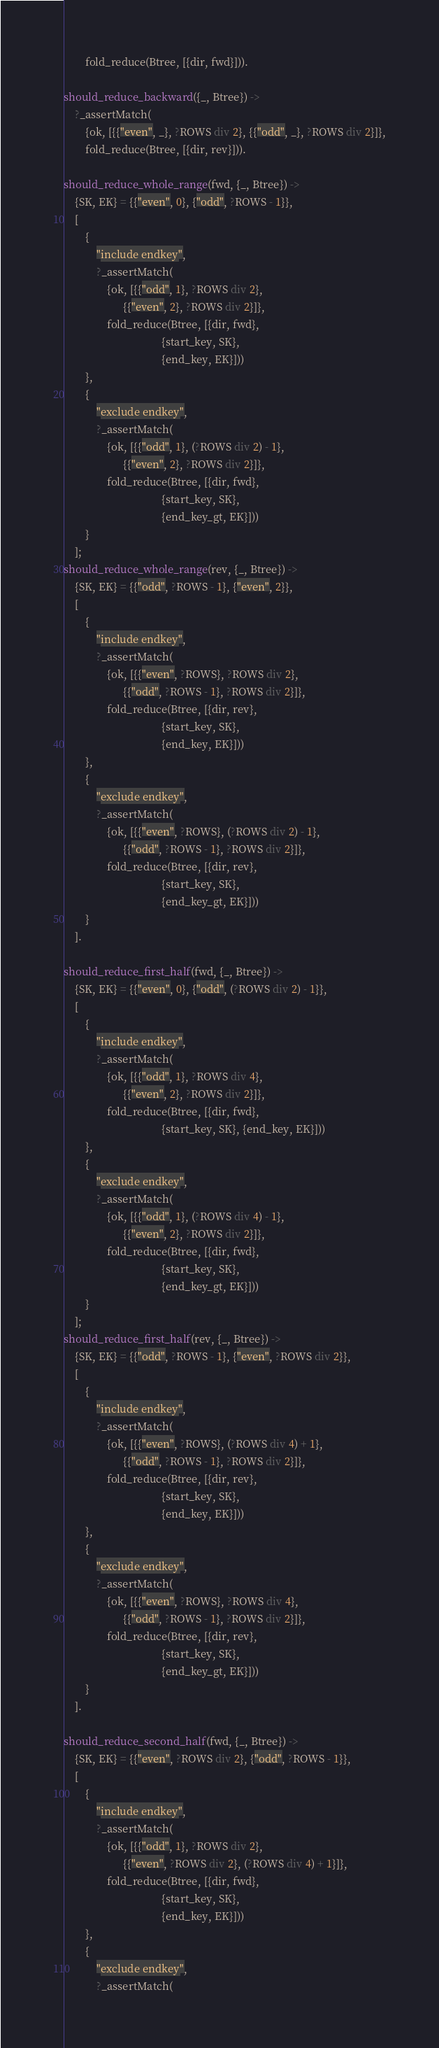<code> <loc_0><loc_0><loc_500><loc_500><_Erlang_>        fold_reduce(Btree, [{dir, fwd}])).

should_reduce_backward({_, Btree}) ->
    ?_assertMatch(
        {ok, [{{"even", _}, ?ROWS div 2}, {{"odd", _}, ?ROWS div 2}]},
        fold_reduce(Btree, [{dir, rev}])).

should_reduce_whole_range(fwd, {_, Btree}) ->
    {SK, EK} = {{"even", 0}, {"odd", ?ROWS - 1}},
    [
        {
            "include endkey",
            ?_assertMatch(
                {ok, [{{"odd", 1}, ?ROWS div 2},
                      {{"even", 2}, ?ROWS div 2}]},
                fold_reduce(Btree, [{dir, fwd},
                                    {start_key, SK},
                                    {end_key, EK}]))
        },
        {
            "exclude endkey",
            ?_assertMatch(
                {ok, [{{"odd", 1}, (?ROWS div 2) - 1},
                      {{"even", 2}, ?ROWS div 2}]},
                fold_reduce(Btree, [{dir, fwd},
                                    {start_key, SK},
                                    {end_key_gt, EK}]))
        }
    ];
should_reduce_whole_range(rev, {_, Btree}) ->
    {SK, EK} = {{"odd", ?ROWS - 1}, {"even", 2}},
    [
        {
            "include endkey",
            ?_assertMatch(
                {ok, [{{"even", ?ROWS}, ?ROWS div 2},
                      {{"odd", ?ROWS - 1}, ?ROWS div 2}]},
                fold_reduce(Btree, [{dir, rev},
                                    {start_key, SK},
                                    {end_key, EK}]))
        },
        {
            "exclude endkey",
            ?_assertMatch(
                {ok, [{{"even", ?ROWS}, (?ROWS div 2) - 1},
                      {{"odd", ?ROWS - 1}, ?ROWS div 2}]},
                fold_reduce(Btree, [{dir, rev},
                                    {start_key, SK},
                                    {end_key_gt, EK}]))
        }
    ].

should_reduce_first_half(fwd, {_, Btree}) ->
    {SK, EK} = {{"even", 0}, {"odd", (?ROWS div 2) - 1}},
    [
        {
            "include endkey",
            ?_assertMatch(
                {ok, [{{"odd", 1}, ?ROWS div 4},
                      {{"even", 2}, ?ROWS div 2}]},
                fold_reduce(Btree, [{dir, fwd},
                                    {start_key, SK}, {end_key, EK}]))
        },
        {
            "exclude endkey",
            ?_assertMatch(
                {ok, [{{"odd", 1}, (?ROWS div 4) - 1},
                      {{"even", 2}, ?ROWS div 2}]},
                fold_reduce(Btree, [{dir, fwd},
                                    {start_key, SK},
                                    {end_key_gt, EK}]))
        }
    ];
should_reduce_first_half(rev, {_, Btree}) ->
    {SK, EK} = {{"odd", ?ROWS - 1}, {"even", ?ROWS div 2}},
    [
        {
            "include endkey",
            ?_assertMatch(
                {ok, [{{"even", ?ROWS}, (?ROWS div 4) + 1},
                      {{"odd", ?ROWS - 1}, ?ROWS div 2}]},
                fold_reduce(Btree, [{dir, rev},
                                    {start_key, SK},
                                    {end_key, EK}]))
        },
        {
            "exclude endkey",
            ?_assertMatch(
                {ok, [{{"even", ?ROWS}, ?ROWS div 4},
                      {{"odd", ?ROWS - 1}, ?ROWS div 2}]},
                fold_reduce(Btree, [{dir, rev},
                                    {start_key, SK},
                                    {end_key_gt, EK}]))
        }
    ].

should_reduce_second_half(fwd, {_, Btree}) ->
    {SK, EK} = {{"even", ?ROWS div 2}, {"odd", ?ROWS - 1}},
    [
        {
            "include endkey",
            ?_assertMatch(
                {ok, [{{"odd", 1}, ?ROWS div 2},
                      {{"even", ?ROWS div 2}, (?ROWS div 4) + 1}]},
                fold_reduce(Btree, [{dir, fwd},
                                    {start_key, SK},
                                    {end_key, EK}]))
        },
        {
            "exclude endkey",
            ?_assertMatch(</code> 